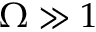Convert formula to latex. <formula><loc_0><loc_0><loc_500><loc_500>\Omega \gg 1</formula> 